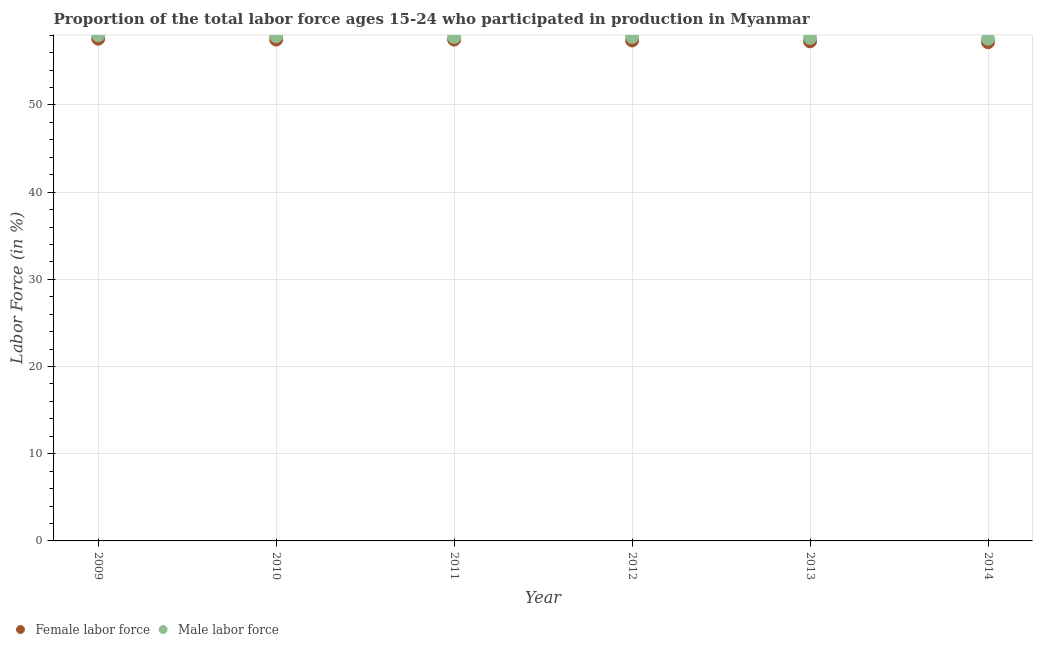What is the percentage of female labor force in 2011?
Offer a very short reply. 57.5. Across all years, what is the minimum percentage of female labor force?
Your response must be concise. 57.2. In which year was the percentage of female labor force maximum?
Your answer should be very brief. 2009. What is the total percentage of male labour force in the graph?
Give a very brief answer. 346.8. What is the difference between the percentage of male labour force in 2010 and that in 2013?
Offer a terse response. 0.2. What is the difference between the percentage of male labour force in 2011 and the percentage of female labor force in 2010?
Keep it short and to the point. 0.3. What is the average percentage of male labour force per year?
Provide a short and direct response. 57.8. In the year 2011, what is the difference between the percentage of female labor force and percentage of male labour force?
Provide a succinct answer. -0.3. In how many years, is the percentage of female labor force greater than 56 %?
Your response must be concise. 6. Is the difference between the percentage of male labour force in 2010 and 2013 greater than the difference between the percentage of female labor force in 2010 and 2013?
Provide a short and direct response. No. What is the difference between the highest and the second highest percentage of male labour force?
Provide a short and direct response. 0.1. What is the difference between the highest and the lowest percentage of female labor force?
Offer a terse response. 0.4. In how many years, is the percentage of male labour force greater than the average percentage of male labour force taken over all years?
Provide a succinct answer. 2. Is the sum of the percentage of female labor force in 2012 and 2013 greater than the maximum percentage of male labour force across all years?
Your response must be concise. Yes. Does the percentage of male labour force monotonically increase over the years?
Offer a very short reply. No. Is the percentage of female labor force strictly greater than the percentage of male labour force over the years?
Give a very brief answer. No. What is the difference between two consecutive major ticks on the Y-axis?
Provide a short and direct response. 10. How many legend labels are there?
Your answer should be very brief. 2. What is the title of the graph?
Your response must be concise. Proportion of the total labor force ages 15-24 who participated in production in Myanmar. Does "All education staff compensation" appear as one of the legend labels in the graph?
Your response must be concise. No. What is the Labor Force (in %) of Female labor force in 2009?
Keep it short and to the point. 57.6. What is the Labor Force (in %) in Male labor force in 2009?
Your answer should be very brief. 58. What is the Labor Force (in %) of Female labor force in 2010?
Your answer should be compact. 57.5. What is the Labor Force (in %) in Male labor force in 2010?
Keep it short and to the point. 57.9. What is the Labor Force (in %) of Female labor force in 2011?
Provide a succinct answer. 57.5. What is the Labor Force (in %) of Male labor force in 2011?
Offer a very short reply. 57.8. What is the Labor Force (in %) in Female labor force in 2012?
Offer a terse response. 57.4. What is the Labor Force (in %) of Male labor force in 2012?
Offer a very short reply. 57.8. What is the Labor Force (in %) of Female labor force in 2013?
Ensure brevity in your answer.  57.3. What is the Labor Force (in %) in Male labor force in 2013?
Offer a terse response. 57.7. What is the Labor Force (in %) in Female labor force in 2014?
Give a very brief answer. 57.2. What is the Labor Force (in %) in Male labor force in 2014?
Your answer should be very brief. 57.6. Across all years, what is the maximum Labor Force (in %) of Female labor force?
Give a very brief answer. 57.6. Across all years, what is the maximum Labor Force (in %) of Male labor force?
Give a very brief answer. 58. Across all years, what is the minimum Labor Force (in %) of Female labor force?
Provide a succinct answer. 57.2. Across all years, what is the minimum Labor Force (in %) in Male labor force?
Provide a succinct answer. 57.6. What is the total Labor Force (in %) of Female labor force in the graph?
Offer a terse response. 344.5. What is the total Labor Force (in %) of Male labor force in the graph?
Your answer should be very brief. 346.8. What is the difference between the Labor Force (in %) of Female labor force in 2009 and that in 2010?
Your response must be concise. 0.1. What is the difference between the Labor Force (in %) of Male labor force in 2009 and that in 2010?
Your response must be concise. 0.1. What is the difference between the Labor Force (in %) of Male labor force in 2009 and that in 2012?
Give a very brief answer. 0.2. What is the difference between the Labor Force (in %) of Female labor force in 2009 and that in 2013?
Your answer should be very brief. 0.3. What is the difference between the Labor Force (in %) of Male labor force in 2009 and that in 2013?
Give a very brief answer. 0.3. What is the difference between the Labor Force (in %) in Female labor force in 2010 and that in 2011?
Your answer should be very brief. 0. What is the difference between the Labor Force (in %) of Female labor force in 2010 and that in 2013?
Offer a very short reply. 0.2. What is the difference between the Labor Force (in %) in Male labor force in 2010 and that in 2013?
Your response must be concise. 0.2. What is the difference between the Labor Force (in %) of Male labor force in 2010 and that in 2014?
Ensure brevity in your answer.  0.3. What is the difference between the Labor Force (in %) of Female labor force in 2011 and that in 2013?
Your answer should be compact. 0.2. What is the difference between the Labor Force (in %) in Male labor force in 2011 and that in 2013?
Your answer should be very brief. 0.1. What is the difference between the Labor Force (in %) of Female labor force in 2012 and that in 2013?
Give a very brief answer. 0.1. What is the difference between the Labor Force (in %) in Male labor force in 2012 and that in 2014?
Your answer should be compact. 0.2. What is the difference between the Labor Force (in %) of Female labor force in 2013 and that in 2014?
Ensure brevity in your answer.  0.1. What is the difference between the Labor Force (in %) in Female labor force in 2009 and the Labor Force (in %) in Male labor force in 2012?
Offer a terse response. -0.2. What is the difference between the Labor Force (in %) of Female labor force in 2009 and the Labor Force (in %) of Male labor force in 2014?
Offer a very short reply. 0. What is the difference between the Labor Force (in %) of Female labor force in 2010 and the Labor Force (in %) of Male labor force in 2011?
Make the answer very short. -0.3. What is the difference between the Labor Force (in %) of Female labor force in 2010 and the Labor Force (in %) of Male labor force in 2013?
Your response must be concise. -0.2. What is the difference between the Labor Force (in %) of Female labor force in 2010 and the Labor Force (in %) of Male labor force in 2014?
Provide a succinct answer. -0.1. What is the difference between the Labor Force (in %) of Female labor force in 2013 and the Labor Force (in %) of Male labor force in 2014?
Offer a terse response. -0.3. What is the average Labor Force (in %) in Female labor force per year?
Ensure brevity in your answer.  57.42. What is the average Labor Force (in %) in Male labor force per year?
Offer a very short reply. 57.8. In the year 2011, what is the difference between the Labor Force (in %) of Female labor force and Labor Force (in %) of Male labor force?
Provide a short and direct response. -0.3. In the year 2013, what is the difference between the Labor Force (in %) in Female labor force and Labor Force (in %) in Male labor force?
Offer a terse response. -0.4. What is the ratio of the Labor Force (in %) in Female labor force in 2009 to that in 2010?
Provide a short and direct response. 1. What is the ratio of the Labor Force (in %) in Male labor force in 2009 to that in 2010?
Offer a terse response. 1. What is the ratio of the Labor Force (in %) in Male labor force in 2009 to that in 2012?
Offer a very short reply. 1. What is the ratio of the Labor Force (in %) of Female labor force in 2009 to that in 2013?
Your answer should be very brief. 1.01. What is the ratio of the Labor Force (in %) in Male labor force in 2009 to that in 2013?
Give a very brief answer. 1.01. What is the ratio of the Labor Force (in %) of Female labor force in 2009 to that in 2014?
Ensure brevity in your answer.  1.01. What is the ratio of the Labor Force (in %) of Female labor force in 2010 to that in 2011?
Offer a very short reply. 1. What is the ratio of the Labor Force (in %) of Male labor force in 2010 to that in 2012?
Keep it short and to the point. 1. What is the ratio of the Labor Force (in %) of Female labor force in 2010 to that in 2013?
Your answer should be very brief. 1. What is the ratio of the Labor Force (in %) of Female labor force in 2010 to that in 2014?
Offer a terse response. 1.01. What is the ratio of the Labor Force (in %) in Male labor force in 2010 to that in 2014?
Offer a very short reply. 1.01. What is the ratio of the Labor Force (in %) of Female labor force in 2011 to that in 2012?
Give a very brief answer. 1. What is the ratio of the Labor Force (in %) of Female labor force in 2011 to that in 2013?
Offer a terse response. 1. What is the ratio of the Labor Force (in %) of Male labor force in 2013 to that in 2014?
Ensure brevity in your answer.  1. What is the difference between the highest and the second highest Labor Force (in %) of Female labor force?
Give a very brief answer. 0.1. What is the difference between the highest and the second highest Labor Force (in %) in Male labor force?
Provide a short and direct response. 0.1. What is the difference between the highest and the lowest Labor Force (in %) of Female labor force?
Your answer should be compact. 0.4. What is the difference between the highest and the lowest Labor Force (in %) in Male labor force?
Keep it short and to the point. 0.4. 